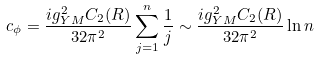Convert formula to latex. <formula><loc_0><loc_0><loc_500><loc_500>c _ { \phi } = { \frac { i g _ { Y M } ^ { 2 } C _ { 2 } ( R ) } { 3 2 \pi ^ { 2 } } } \sum _ { j = 1 } ^ { n } { \frac { 1 } { j } } \sim { \frac { i g _ { Y M } ^ { 2 } C _ { 2 } ( R ) } { 3 2 \pi ^ { 2 } } } \ln n</formula> 